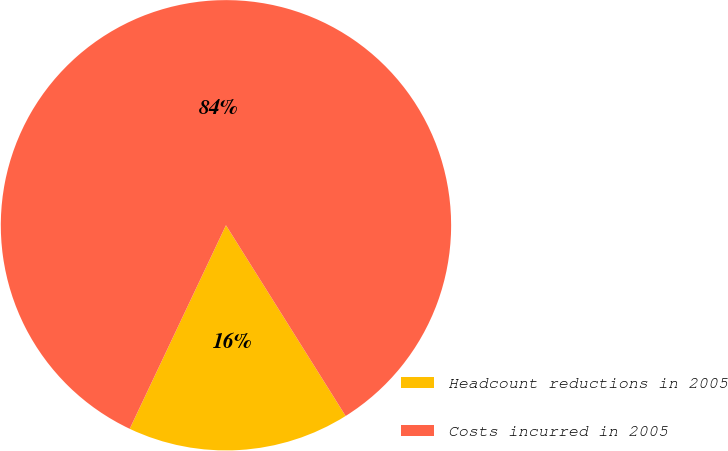<chart> <loc_0><loc_0><loc_500><loc_500><pie_chart><fcel>Headcount reductions in 2005<fcel>Costs incurred in 2005<nl><fcel>15.95%<fcel>84.05%<nl></chart> 